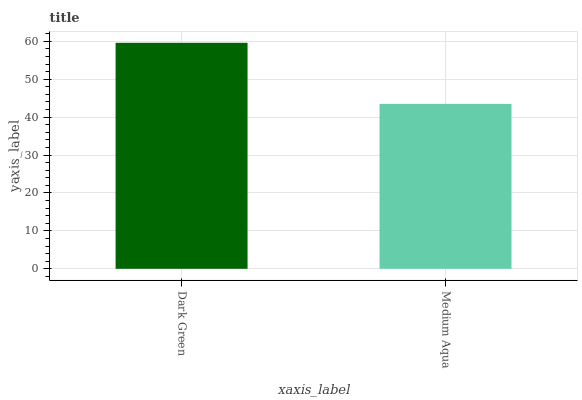Is Medium Aqua the minimum?
Answer yes or no. Yes. Is Dark Green the maximum?
Answer yes or no. Yes. Is Medium Aqua the maximum?
Answer yes or no. No. Is Dark Green greater than Medium Aqua?
Answer yes or no. Yes. Is Medium Aqua less than Dark Green?
Answer yes or no. Yes. Is Medium Aqua greater than Dark Green?
Answer yes or no. No. Is Dark Green less than Medium Aqua?
Answer yes or no. No. Is Dark Green the high median?
Answer yes or no. Yes. Is Medium Aqua the low median?
Answer yes or no. Yes. Is Medium Aqua the high median?
Answer yes or no. No. Is Dark Green the low median?
Answer yes or no. No. 